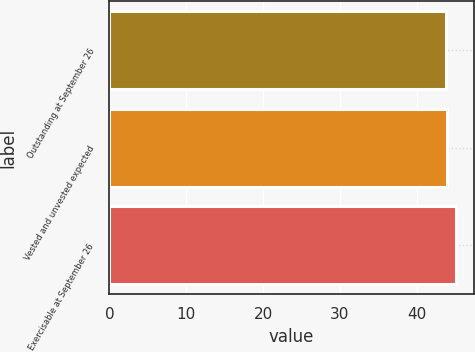Convert chart to OTSL. <chart><loc_0><loc_0><loc_500><loc_500><bar_chart><fcel>Outstanding at September 26<fcel>Vested and unvested expected<fcel>Exercisable at September 26<nl><fcel>43.81<fcel>43.97<fcel>45.13<nl></chart> 